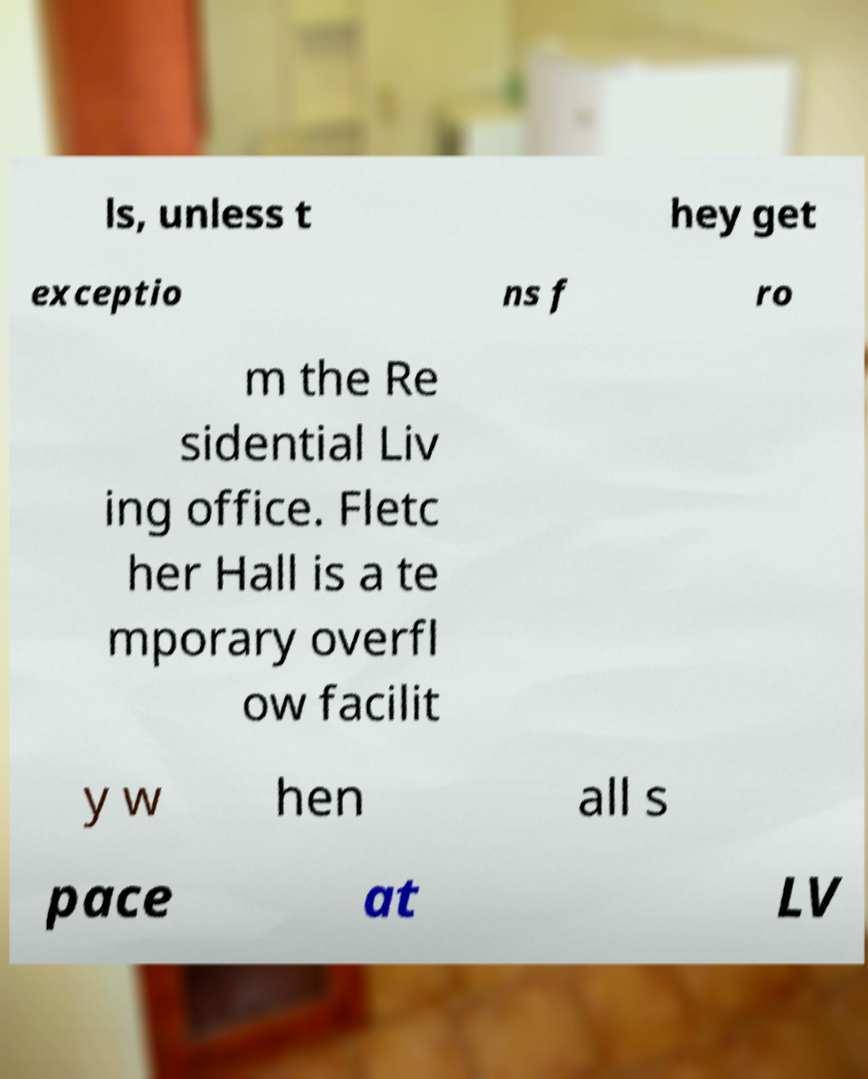Can you read and provide the text displayed in the image?This photo seems to have some interesting text. Can you extract and type it out for me? ls, unless t hey get exceptio ns f ro m the Re sidential Liv ing office. Fletc her Hall is a te mporary overfl ow facilit y w hen all s pace at LV 